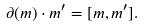Convert formula to latex. <formula><loc_0><loc_0><loc_500><loc_500>\partial ( m ) \cdot m ^ { \prime } = [ m , m ^ { \prime } ] .</formula> 